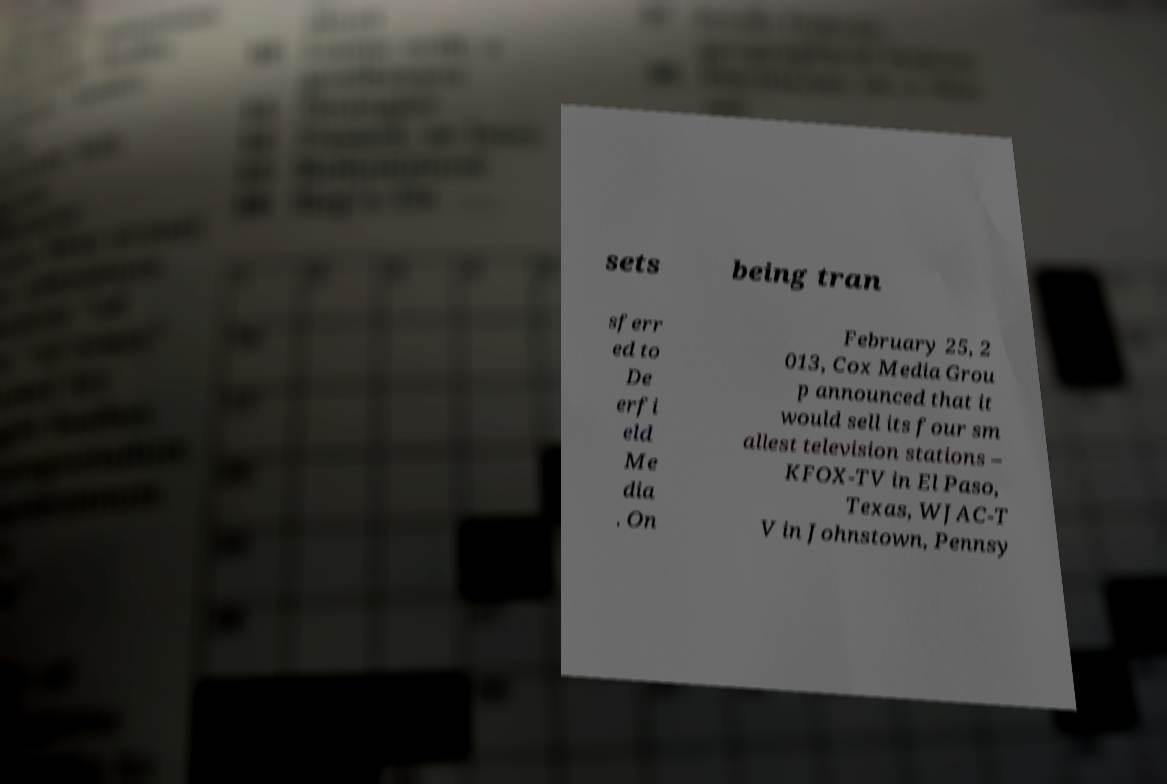For documentation purposes, I need the text within this image transcribed. Could you provide that? sets being tran sferr ed to De erfi eld Me dia . On February 25, 2 013, Cox Media Grou p announced that it would sell its four sm allest television stations – KFOX-TV in El Paso, Texas, WJAC-T V in Johnstown, Pennsy 